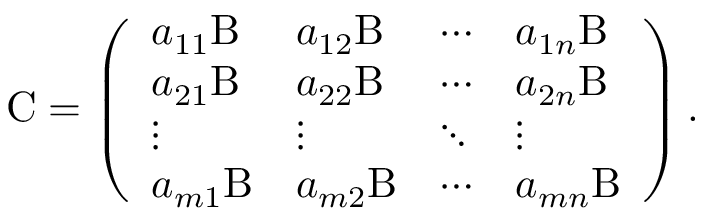Convert formula to latex. <formula><loc_0><loc_0><loc_500><loc_500>C = \left ( \begin{array} { l l l l } { a _ { 1 1 } B } & { a _ { 1 2 } B } & { \cdots } & { a _ { 1 n } B } \\ { a _ { 2 1 } B } & { a _ { 2 2 } B } & { \cdots } & { a _ { 2 n } B } \\ { \vdots } & { \vdots } & { \ddots } & { \vdots } \\ { a _ { m 1 } B } & { a _ { m 2 } B } & { \cdots } & { a _ { m n } B } \end{array} \right ) .</formula> 